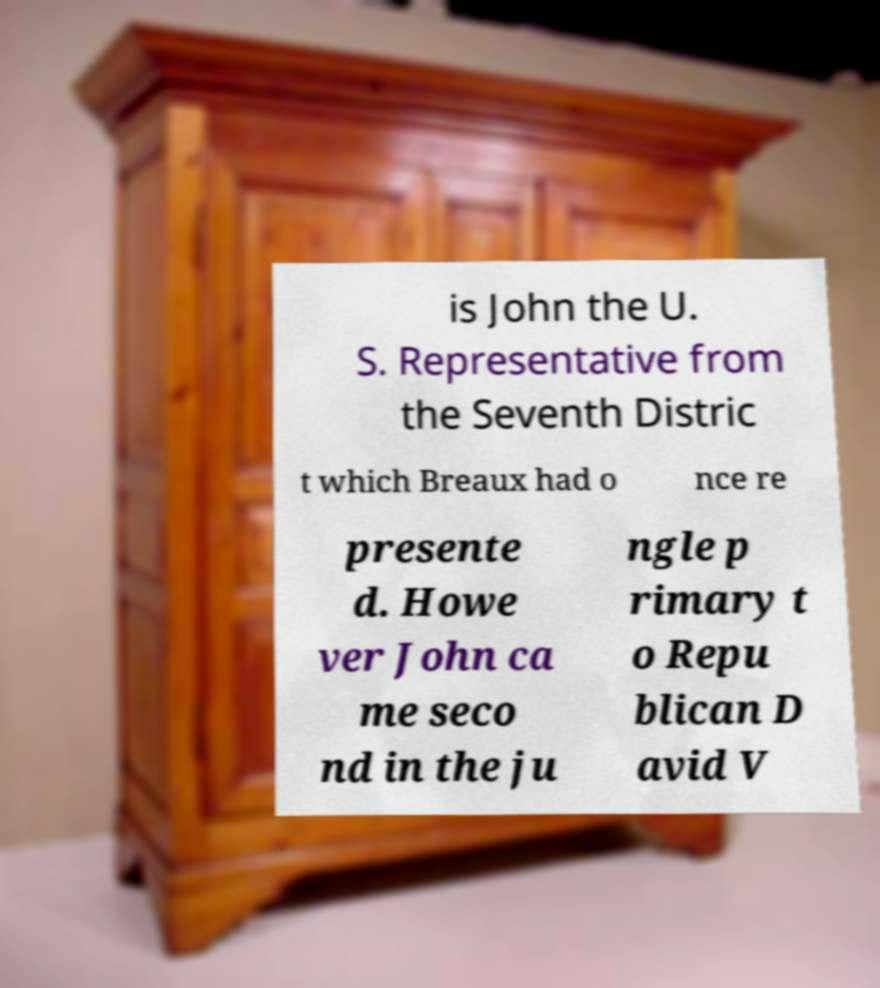Please identify and transcribe the text found in this image. is John the U. S. Representative from the Seventh Distric t which Breaux had o nce re presente d. Howe ver John ca me seco nd in the ju ngle p rimary t o Repu blican D avid V 